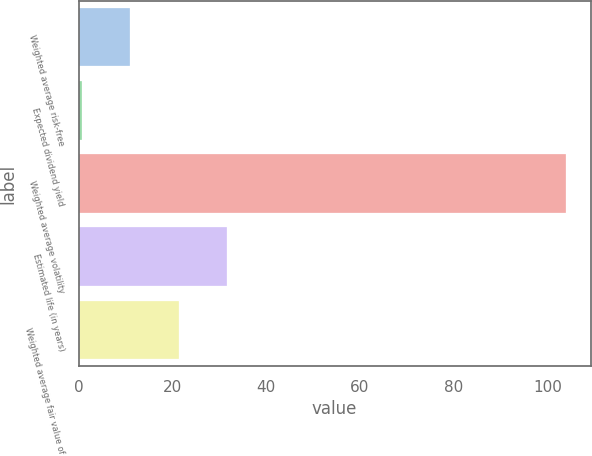<chart> <loc_0><loc_0><loc_500><loc_500><bar_chart><fcel>Weighted average risk-free<fcel>Expected dividend yield<fcel>Weighted average volatility<fcel>Estimated life (in years)<fcel>Weighted average fair value of<nl><fcel>11.01<fcel>0.68<fcel>104<fcel>31.67<fcel>21.34<nl></chart> 